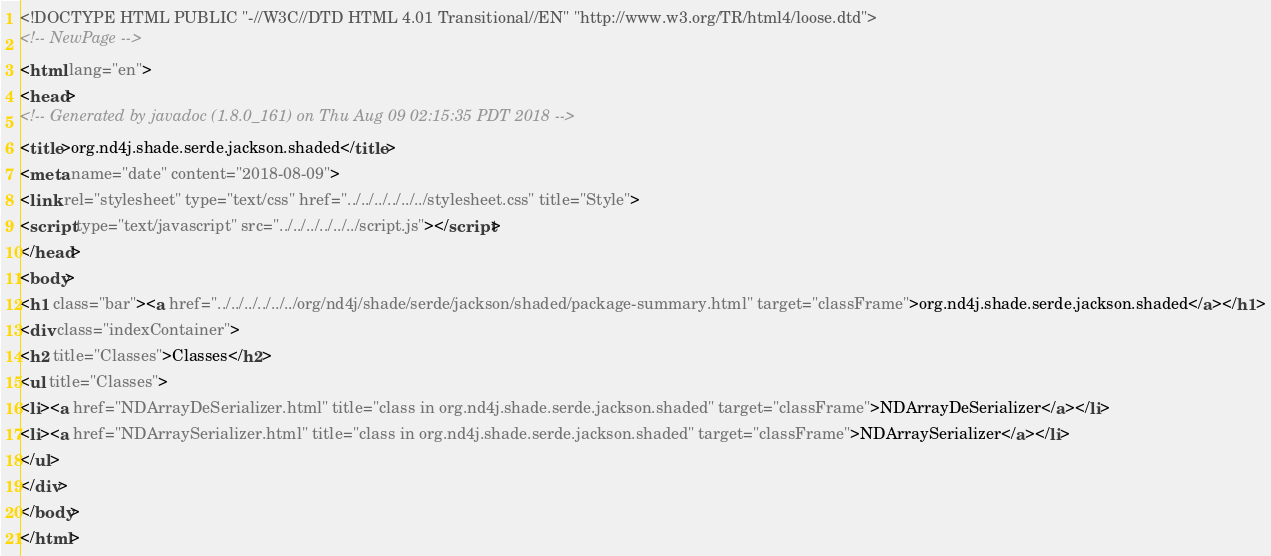Convert code to text. <code><loc_0><loc_0><loc_500><loc_500><_HTML_><!DOCTYPE HTML PUBLIC "-//W3C//DTD HTML 4.01 Transitional//EN" "http://www.w3.org/TR/html4/loose.dtd">
<!-- NewPage -->
<html lang="en">
<head>
<!-- Generated by javadoc (1.8.0_161) on Thu Aug 09 02:15:35 PDT 2018 -->
<title>org.nd4j.shade.serde.jackson.shaded</title>
<meta name="date" content="2018-08-09">
<link rel="stylesheet" type="text/css" href="../../../../../../stylesheet.css" title="Style">
<script type="text/javascript" src="../../../../../../script.js"></script>
</head>
<body>
<h1 class="bar"><a href="../../../../../../org/nd4j/shade/serde/jackson/shaded/package-summary.html" target="classFrame">org.nd4j.shade.serde.jackson.shaded</a></h1>
<div class="indexContainer">
<h2 title="Classes">Classes</h2>
<ul title="Classes">
<li><a href="NDArrayDeSerializer.html" title="class in org.nd4j.shade.serde.jackson.shaded" target="classFrame">NDArrayDeSerializer</a></li>
<li><a href="NDArraySerializer.html" title="class in org.nd4j.shade.serde.jackson.shaded" target="classFrame">NDArraySerializer</a></li>
</ul>
</div>
</body>
</html>
</code> 